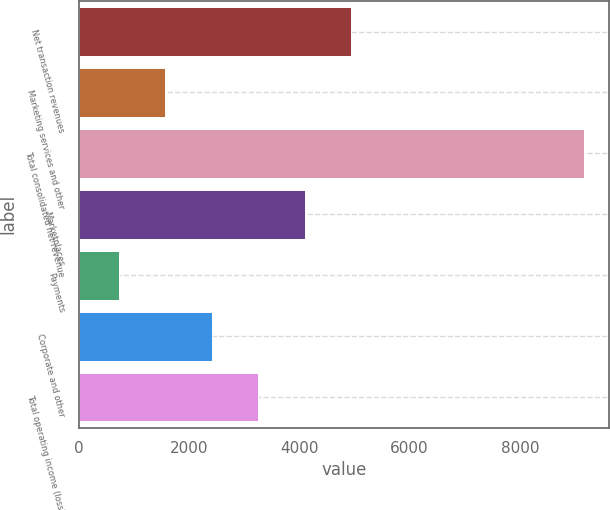Convert chart to OTSL. <chart><loc_0><loc_0><loc_500><loc_500><bar_chart><fcel>Net transaction revenues<fcel>Marketing services and other<fcel>Total consolidated net revenue<fcel>Marketplaces<fcel>Payments<fcel>Corporate and other<fcel>Total operating income (loss)<nl><fcel>4939<fcel>1565.4<fcel>9156<fcel>4095.6<fcel>722<fcel>2408.8<fcel>3252.2<nl></chart> 